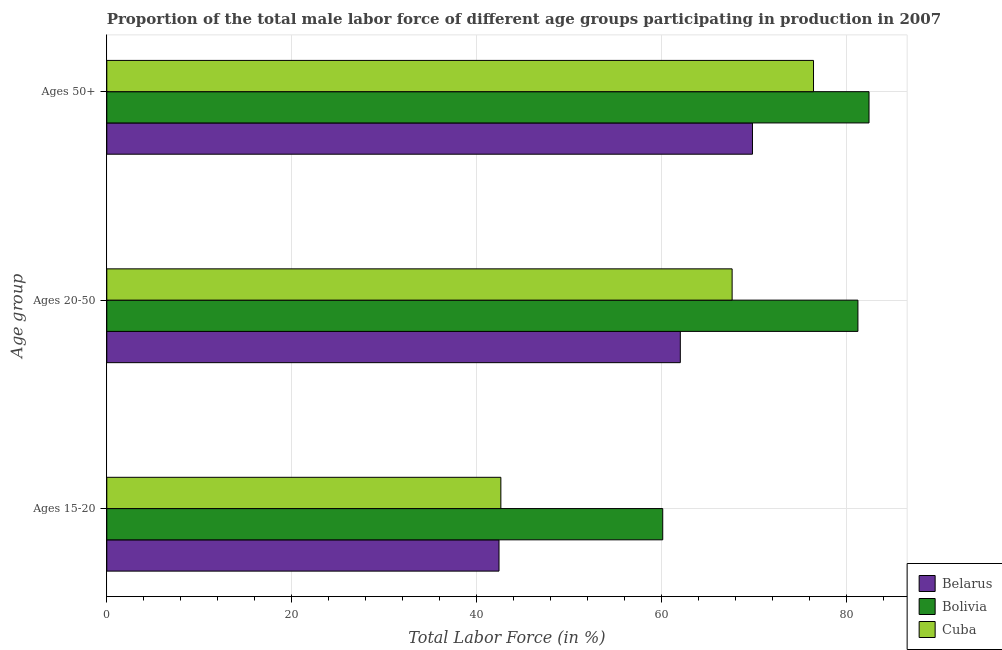How many different coloured bars are there?
Ensure brevity in your answer.  3. How many bars are there on the 3rd tick from the top?
Your response must be concise. 3. What is the label of the 3rd group of bars from the top?
Make the answer very short. Ages 15-20. What is the percentage of male labor force within the age group 15-20 in Cuba?
Keep it short and to the point. 42.6. Across all countries, what is the maximum percentage of male labor force above age 50?
Offer a very short reply. 82.4. Across all countries, what is the minimum percentage of male labor force above age 50?
Ensure brevity in your answer.  69.8. In which country was the percentage of male labor force above age 50 maximum?
Give a very brief answer. Bolivia. In which country was the percentage of male labor force within the age group 15-20 minimum?
Make the answer very short. Belarus. What is the total percentage of male labor force within the age group 15-20 in the graph?
Provide a short and direct response. 145.1. What is the difference between the percentage of male labor force above age 50 in Belarus and the percentage of male labor force within the age group 20-50 in Cuba?
Give a very brief answer. 2.2. What is the average percentage of male labor force above age 50 per country?
Ensure brevity in your answer.  76.2. What is the difference between the percentage of male labor force within the age group 15-20 and percentage of male labor force within the age group 20-50 in Belarus?
Offer a very short reply. -19.6. In how many countries, is the percentage of male labor force within the age group 20-50 greater than 32 %?
Provide a short and direct response. 3. What is the ratio of the percentage of male labor force within the age group 20-50 in Cuba to that in Belarus?
Provide a succinct answer. 1.09. Is the percentage of male labor force within the age group 20-50 in Belarus less than that in Cuba?
Offer a terse response. Yes. What is the difference between the highest and the second highest percentage of male labor force within the age group 15-20?
Keep it short and to the point. 17.5. What is the difference between the highest and the lowest percentage of male labor force within the age group 20-50?
Your response must be concise. 19.2. Is the sum of the percentage of male labor force above age 50 in Cuba and Belarus greater than the maximum percentage of male labor force within the age group 15-20 across all countries?
Offer a terse response. Yes. What does the 1st bar from the top in Ages 15-20 represents?
Ensure brevity in your answer.  Cuba. What does the 3rd bar from the bottom in Ages 20-50 represents?
Give a very brief answer. Cuba. Is it the case that in every country, the sum of the percentage of male labor force within the age group 15-20 and percentage of male labor force within the age group 20-50 is greater than the percentage of male labor force above age 50?
Offer a very short reply. Yes. How many countries are there in the graph?
Make the answer very short. 3. Are the values on the major ticks of X-axis written in scientific E-notation?
Give a very brief answer. No. Where does the legend appear in the graph?
Provide a succinct answer. Bottom right. What is the title of the graph?
Provide a short and direct response. Proportion of the total male labor force of different age groups participating in production in 2007. What is the label or title of the X-axis?
Your answer should be very brief. Total Labor Force (in %). What is the label or title of the Y-axis?
Your response must be concise. Age group. What is the Total Labor Force (in %) of Belarus in Ages 15-20?
Your answer should be compact. 42.4. What is the Total Labor Force (in %) of Bolivia in Ages 15-20?
Make the answer very short. 60.1. What is the Total Labor Force (in %) in Cuba in Ages 15-20?
Your response must be concise. 42.6. What is the Total Labor Force (in %) in Bolivia in Ages 20-50?
Offer a terse response. 81.2. What is the Total Labor Force (in %) in Cuba in Ages 20-50?
Your answer should be very brief. 67.6. What is the Total Labor Force (in %) of Belarus in Ages 50+?
Make the answer very short. 69.8. What is the Total Labor Force (in %) in Bolivia in Ages 50+?
Keep it short and to the point. 82.4. What is the Total Labor Force (in %) in Cuba in Ages 50+?
Ensure brevity in your answer.  76.4. Across all Age group, what is the maximum Total Labor Force (in %) of Belarus?
Ensure brevity in your answer.  69.8. Across all Age group, what is the maximum Total Labor Force (in %) of Bolivia?
Keep it short and to the point. 82.4. Across all Age group, what is the maximum Total Labor Force (in %) of Cuba?
Offer a very short reply. 76.4. Across all Age group, what is the minimum Total Labor Force (in %) of Belarus?
Your response must be concise. 42.4. Across all Age group, what is the minimum Total Labor Force (in %) of Bolivia?
Offer a very short reply. 60.1. Across all Age group, what is the minimum Total Labor Force (in %) in Cuba?
Provide a succinct answer. 42.6. What is the total Total Labor Force (in %) of Belarus in the graph?
Provide a succinct answer. 174.2. What is the total Total Labor Force (in %) of Bolivia in the graph?
Keep it short and to the point. 223.7. What is the total Total Labor Force (in %) of Cuba in the graph?
Your answer should be compact. 186.6. What is the difference between the Total Labor Force (in %) in Belarus in Ages 15-20 and that in Ages 20-50?
Make the answer very short. -19.6. What is the difference between the Total Labor Force (in %) of Bolivia in Ages 15-20 and that in Ages 20-50?
Your response must be concise. -21.1. What is the difference between the Total Labor Force (in %) in Belarus in Ages 15-20 and that in Ages 50+?
Ensure brevity in your answer.  -27.4. What is the difference between the Total Labor Force (in %) in Bolivia in Ages 15-20 and that in Ages 50+?
Your answer should be compact. -22.3. What is the difference between the Total Labor Force (in %) of Cuba in Ages 15-20 and that in Ages 50+?
Make the answer very short. -33.8. What is the difference between the Total Labor Force (in %) of Bolivia in Ages 20-50 and that in Ages 50+?
Keep it short and to the point. -1.2. What is the difference between the Total Labor Force (in %) in Belarus in Ages 15-20 and the Total Labor Force (in %) in Bolivia in Ages 20-50?
Provide a succinct answer. -38.8. What is the difference between the Total Labor Force (in %) of Belarus in Ages 15-20 and the Total Labor Force (in %) of Cuba in Ages 20-50?
Offer a very short reply. -25.2. What is the difference between the Total Labor Force (in %) of Bolivia in Ages 15-20 and the Total Labor Force (in %) of Cuba in Ages 20-50?
Give a very brief answer. -7.5. What is the difference between the Total Labor Force (in %) in Belarus in Ages 15-20 and the Total Labor Force (in %) in Bolivia in Ages 50+?
Give a very brief answer. -40. What is the difference between the Total Labor Force (in %) of Belarus in Ages 15-20 and the Total Labor Force (in %) of Cuba in Ages 50+?
Give a very brief answer. -34. What is the difference between the Total Labor Force (in %) of Bolivia in Ages 15-20 and the Total Labor Force (in %) of Cuba in Ages 50+?
Make the answer very short. -16.3. What is the difference between the Total Labor Force (in %) in Belarus in Ages 20-50 and the Total Labor Force (in %) in Bolivia in Ages 50+?
Provide a short and direct response. -20.4. What is the difference between the Total Labor Force (in %) in Belarus in Ages 20-50 and the Total Labor Force (in %) in Cuba in Ages 50+?
Your response must be concise. -14.4. What is the difference between the Total Labor Force (in %) of Bolivia in Ages 20-50 and the Total Labor Force (in %) of Cuba in Ages 50+?
Offer a terse response. 4.8. What is the average Total Labor Force (in %) of Belarus per Age group?
Keep it short and to the point. 58.07. What is the average Total Labor Force (in %) of Bolivia per Age group?
Give a very brief answer. 74.57. What is the average Total Labor Force (in %) in Cuba per Age group?
Provide a succinct answer. 62.2. What is the difference between the Total Labor Force (in %) in Belarus and Total Labor Force (in %) in Bolivia in Ages 15-20?
Provide a short and direct response. -17.7. What is the difference between the Total Labor Force (in %) of Belarus and Total Labor Force (in %) of Cuba in Ages 15-20?
Provide a short and direct response. -0.2. What is the difference between the Total Labor Force (in %) in Bolivia and Total Labor Force (in %) in Cuba in Ages 15-20?
Your answer should be compact. 17.5. What is the difference between the Total Labor Force (in %) in Belarus and Total Labor Force (in %) in Bolivia in Ages 20-50?
Provide a succinct answer. -19.2. What is the difference between the Total Labor Force (in %) of Bolivia and Total Labor Force (in %) of Cuba in Ages 20-50?
Make the answer very short. 13.6. What is the difference between the Total Labor Force (in %) in Belarus and Total Labor Force (in %) in Cuba in Ages 50+?
Make the answer very short. -6.6. What is the ratio of the Total Labor Force (in %) in Belarus in Ages 15-20 to that in Ages 20-50?
Provide a succinct answer. 0.68. What is the ratio of the Total Labor Force (in %) in Bolivia in Ages 15-20 to that in Ages 20-50?
Offer a terse response. 0.74. What is the ratio of the Total Labor Force (in %) of Cuba in Ages 15-20 to that in Ages 20-50?
Offer a very short reply. 0.63. What is the ratio of the Total Labor Force (in %) in Belarus in Ages 15-20 to that in Ages 50+?
Make the answer very short. 0.61. What is the ratio of the Total Labor Force (in %) of Bolivia in Ages 15-20 to that in Ages 50+?
Make the answer very short. 0.73. What is the ratio of the Total Labor Force (in %) in Cuba in Ages 15-20 to that in Ages 50+?
Your answer should be very brief. 0.56. What is the ratio of the Total Labor Force (in %) of Belarus in Ages 20-50 to that in Ages 50+?
Ensure brevity in your answer.  0.89. What is the ratio of the Total Labor Force (in %) in Bolivia in Ages 20-50 to that in Ages 50+?
Offer a very short reply. 0.99. What is the ratio of the Total Labor Force (in %) of Cuba in Ages 20-50 to that in Ages 50+?
Your response must be concise. 0.88. What is the difference between the highest and the second highest Total Labor Force (in %) in Bolivia?
Offer a very short reply. 1.2. What is the difference between the highest and the second highest Total Labor Force (in %) in Cuba?
Make the answer very short. 8.8. What is the difference between the highest and the lowest Total Labor Force (in %) in Belarus?
Provide a short and direct response. 27.4. What is the difference between the highest and the lowest Total Labor Force (in %) of Bolivia?
Ensure brevity in your answer.  22.3. What is the difference between the highest and the lowest Total Labor Force (in %) of Cuba?
Offer a terse response. 33.8. 